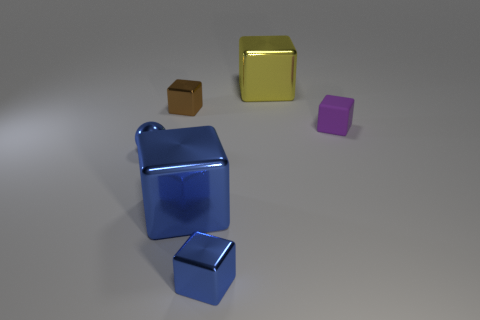Subtract 1 cubes. How many cubes are left? 4 Subtract all purple matte cubes. How many cubes are left? 4 Subtract all purple cubes. How many cubes are left? 4 Subtract all gray blocks. Subtract all brown balls. How many blocks are left? 5 Add 4 big brown balls. How many objects exist? 10 Subtract all balls. How many objects are left? 5 Subtract 1 brown blocks. How many objects are left? 5 Subtract all big objects. Subtract all brown metal objects. How many objects are left? 3 Add 4 big yellow objects. How many big yellow objects are left? 5 Add 2 large yellow shiny spheres. How many large yellow shiny spheres exist? 2 